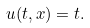Convert formula to latex. <formula><loc_0><loc_0><loc_500><loc_500>u ( t , x ) = t .</formula> 